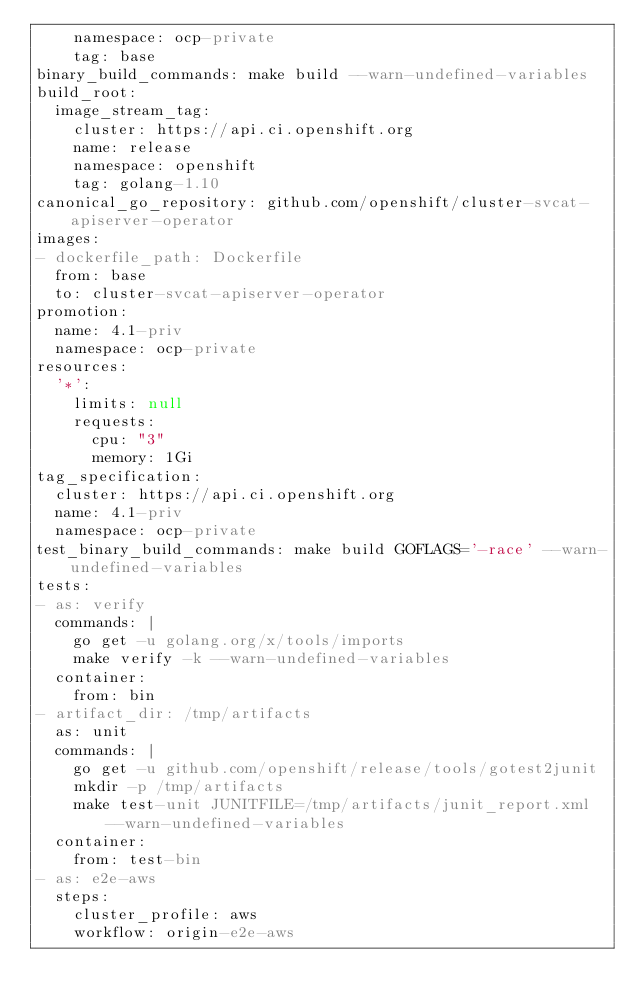Convert code to text. <code><loc_0><loc_0><loc_500><loc_500><_YAML_>    namespace: ocp-private
    tag: base
binary_build_commands: make build --warn-undefined-variables
build_root:
  image_stream_tag:
    cluster: https://api.ci.openshift.org
    name: release
    namespace: openshift
    tag: golang-1.10
canonical_go_repository: github.com/openshift/cluster-svcat-apiserver-operator
images:
- dockerfile_path: Dockerfile
  from: base
  to: cluster-svcat-apiserver-operator
promotion:
  name: 4.1-priv
  namespace: ocp-private
resources:
  '*':
    limits: null
    requests:
      cpu: "3"
      memory: 1Gi
tag_specification:
  cluster: https://api.ci.openshift.org
  name: 4.1-priv
  namespace: ocp-private
test_binary_build_commands: make build GOFLAGS='-race' --warn-undefined-variables
tests:
- as: verify
  commands: |
    go get -u golang.org/x/tools/imports
    make verify -k --warn-undefined-variables
  container:
    from: bin
- artifact_dir: /tmp/artifacts
  as: unit
  commands: |
    go get -u github.com/openshift/release/tools/gotest2junit
    mkdir -p /tmp/artifacts
    make test-unit JUNITFILE=/tmp/artifacts/junit_report.xml --warn-undefined-variables
  container:
    from: test-bin
- as: e2e-aws
  steps:
    cluster_profile: aws
    workflow: origin-e2e-aws
</code> 